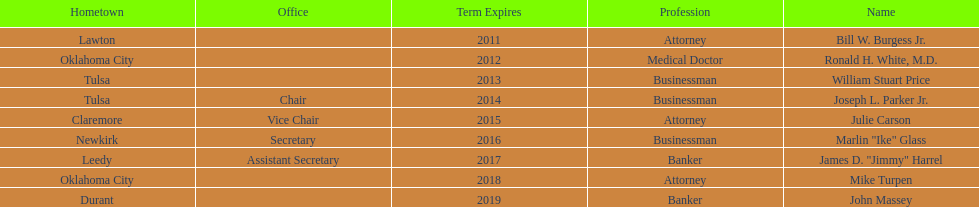Which state regent is from the same hometown as ronald h. white, m.d.? Mike Turpen. 